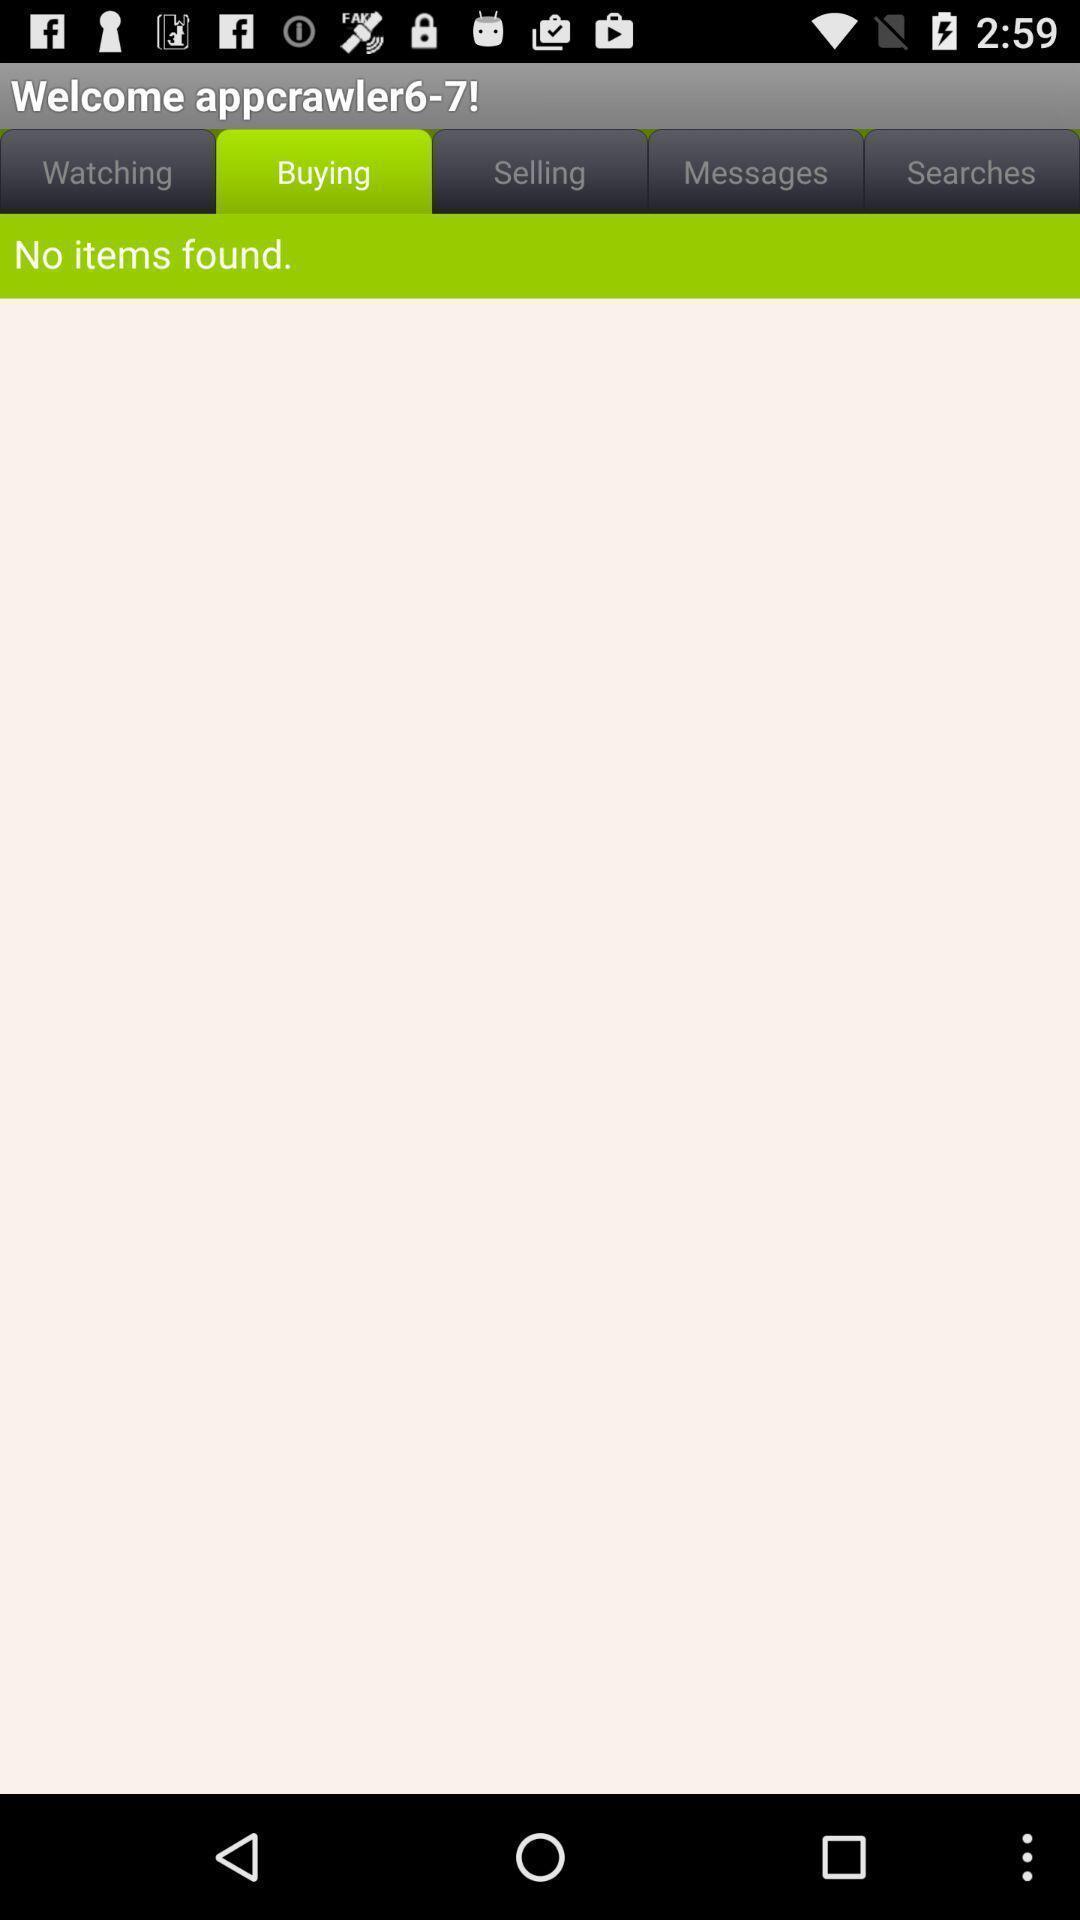What can you discern from this picture? Page showing no items found. 